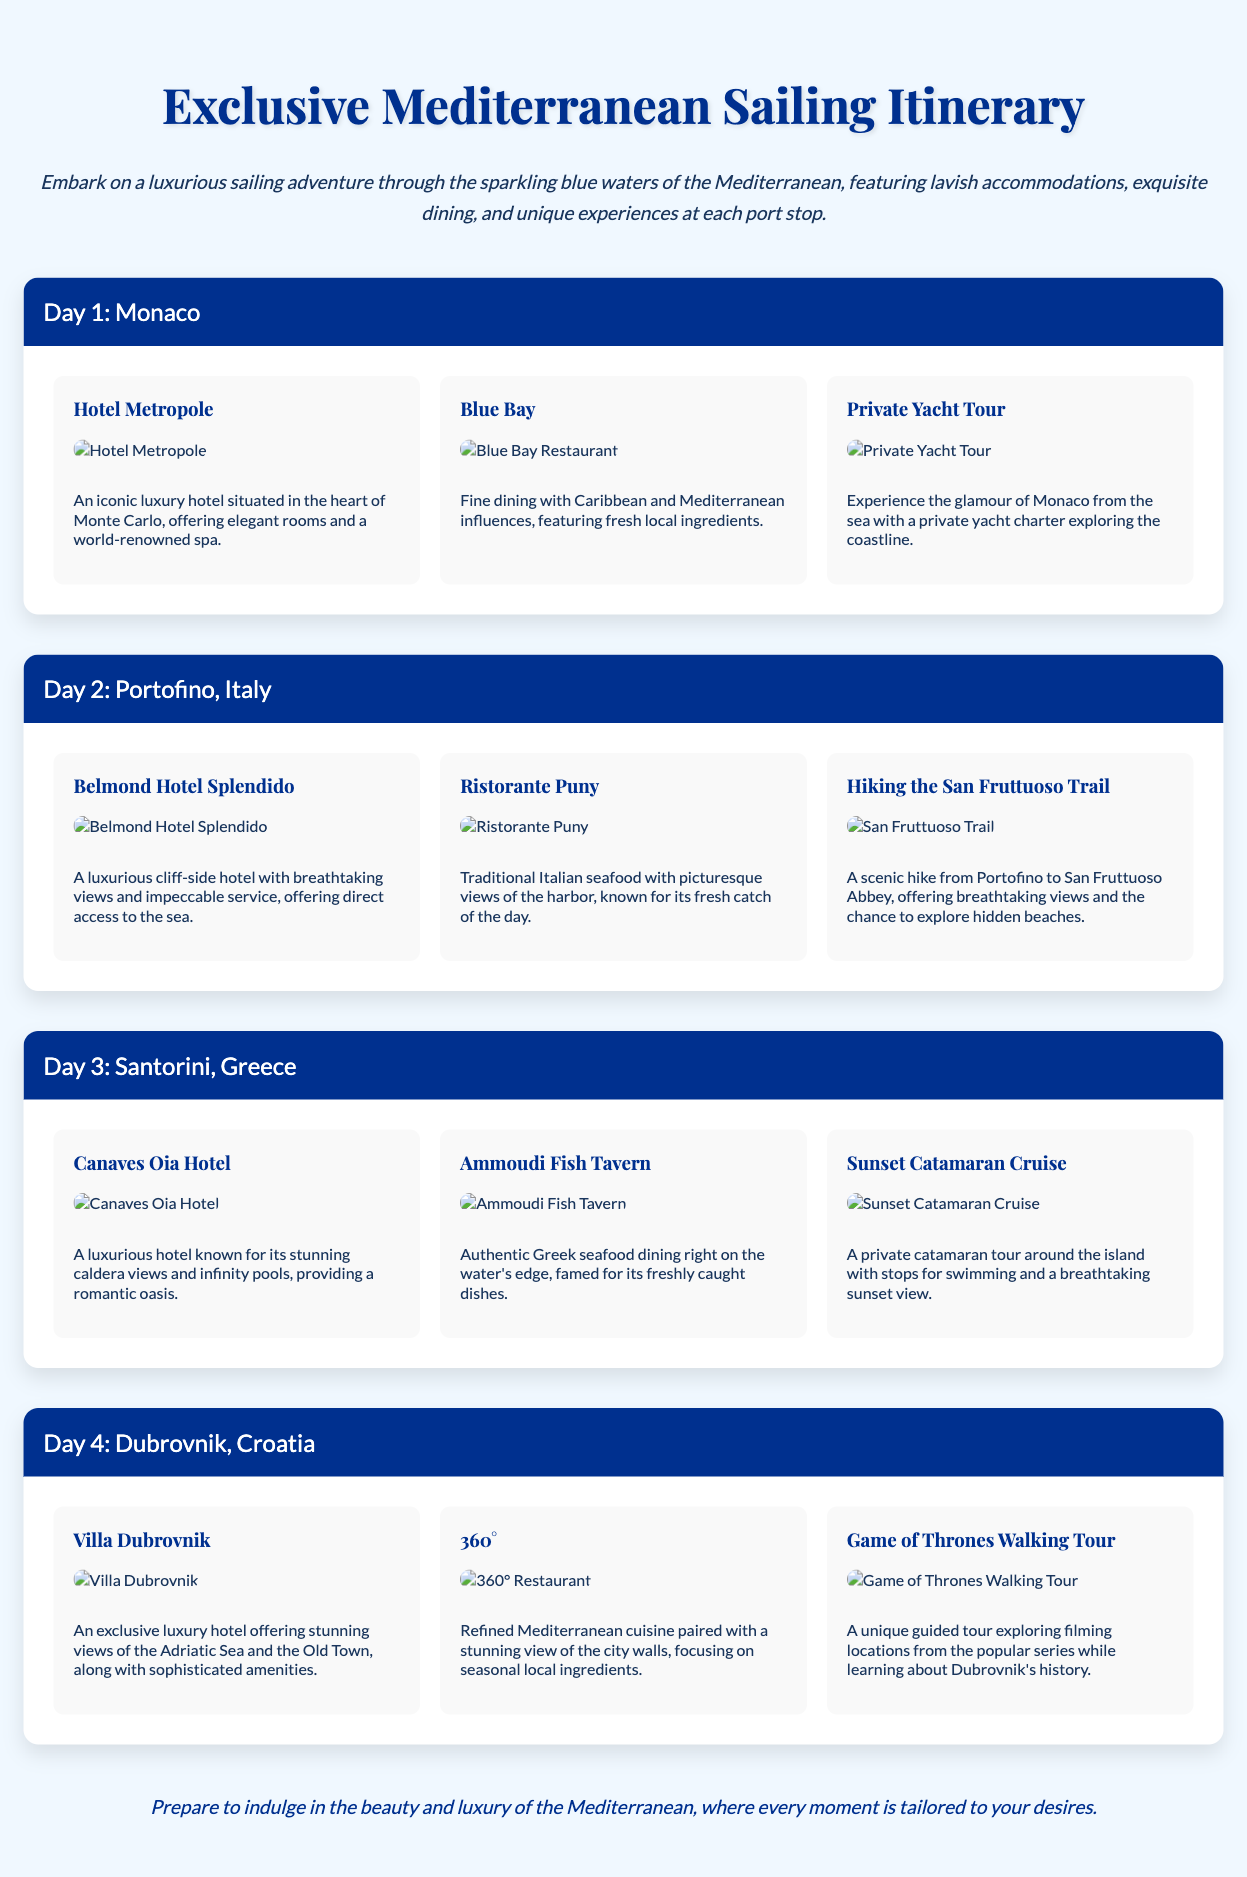What is the first destination on the itinerary? The first destination listed in the itinerary is Monaco.
Answer: Monaco How many days does the sailing trip cover? The itinerary details four days of activities and destinations.
Answer: 4 days What is the name of the hotel in Portofino? The accommodation for Day 2 is the Belmond Hotel Splendido.
Answer: Belmond Hotel Splendido What type of cuisine is served at Blue Bay? Blue Bay offers Caribbean and Mediterranean-inspired fine dining.
Answer: Caribbean and Mediterranean What unique activity is offered in Dubrovnik? The itinerary includes a Game of Thrones Walking Tour as a unique activity.
Answer: Game of Thrones Walking Tour Which destination offers a sunset catamaran cruise? Santorini features a sunset catamaran cruise as part of its itinerary.
Answer: Santorini What hotel is known for its infinity pools? The Canaves Oia Hotel is known for its infinity pools.
Answer: Canaves Oia Hotel What is a highlight of the dining experience in Dubrovnik? The refined Mediterranean cuisine at 360° focuses on seasonal local ingredients.
Answer: Seasonal local ingredients What type of activity can one enjoy in Monaco? A Private Yacht Tour is available as an activity in Monaco.
Answer: Private Yacht Tour 